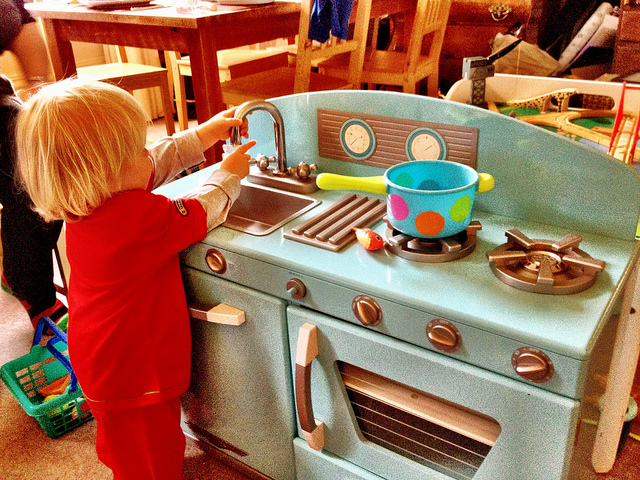Can you describe what kind of toy the child is playing with? Certainly! The child is engaging with a toy kitchen set, which is a miniature, child-safe version of a real kitchen. It's built from durable materials, painted in bright colors, and designed to inspire creative play. Features include toy stove burners, an oven, and a sink, all of which promote developmental skills through role-playing. 